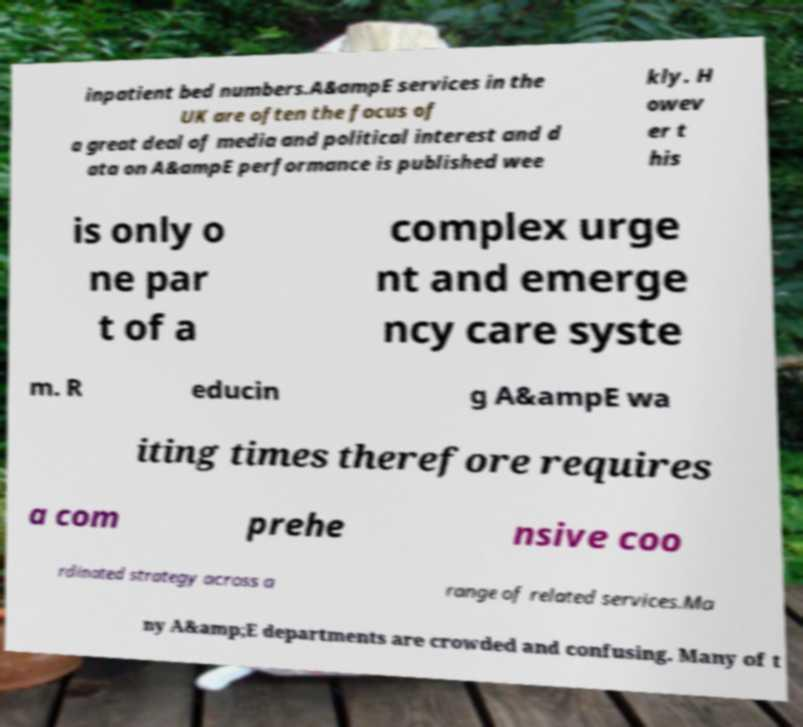I need the written content from this picture converted into text. Can you do that? inpatient bed numbers.A&ampE services in the UK are often the focus of a great deal of media and political interest and d ata on A&ampE performance is published wee kly. H owev er t his is only o ne par t of a complex urge nt and emerge ncy care syste m. R educin g A&ampE wa iting times therefore requires a com prehe nsive coo rdinated strategy across a range of related services.Ma ny A&amp;E departments are crowded and confusing. Many of t 